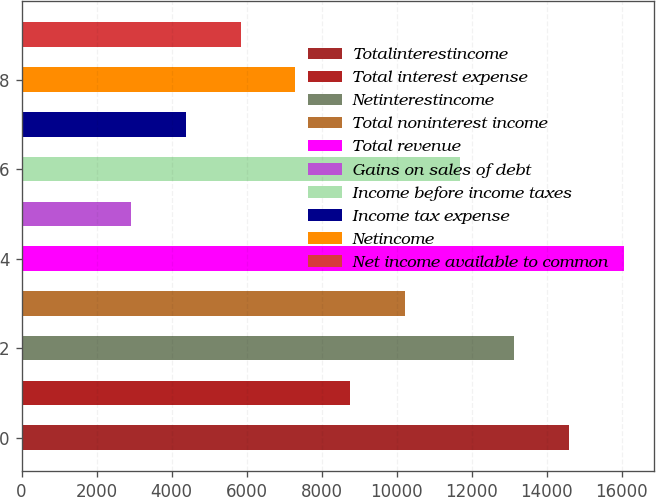Convert chart. <chart><loc_0><loc_0><loc_500><loc_500><bar_chart><fcel>Totalinterestincome<fcel>Total interest expense<fcel>Netinterestincome<fcel>Total noninterest income<fcel>Total revenue<fcel>Gains on sales of debt<fcel>Income before income taxes<fcel>Income tax expense<fcel>Netincome<fcel>Net income available to common<nl><fcel>14592<fcel>8755.68<fcel>13133<fcel>10214.8<fcel>16051.1<fcel>2919.32<fcel>11673.9<fcel>4378.41<fcel>7296.59<fcel>5837.5<nl></chart> 